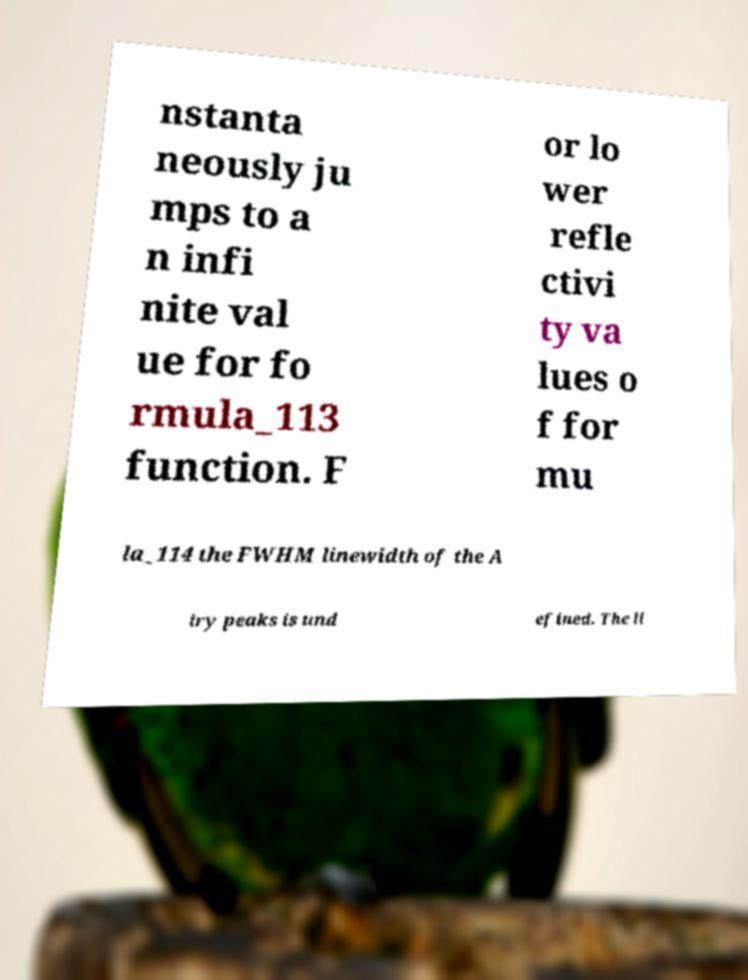Please identify and transcribe the text found in this image. nstanta neously ju mps to a n infi nite val ue for fo rmula_113 function. F or lo wer refle ctivi ty va lues o f for mu la_114 the FWHM linewidth of the A iry peaks is und efined. The li 